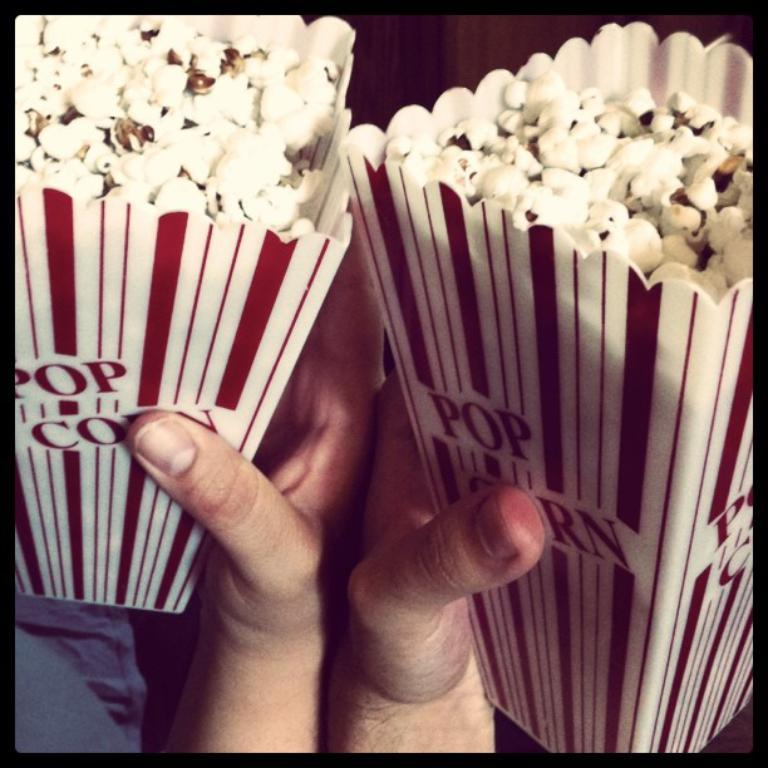What objects are being held by the hands in the image? The hands are holding popcorn packets in the image. Can you describe the appearance of the popcorn packets? The popcorn packets are in white and red colors. What type of hat is being worn by the person holding the popcorn packets? There is no person or hat visible in the image; it only shows two hands holding popcorn packets. 